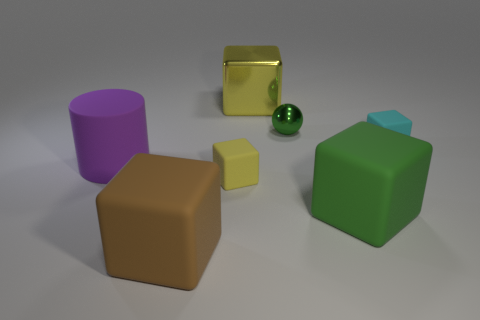Subtract all yellow blocks. How many were subtracted if there are1yellow blocks left? 1 Subtract all brown blocks. How many blocks are left? 4 Subtract all green matte blocks. How many blocks are left? 4 Subtract all blue cubes. Subtract all cyan cylinders. How many cubes are left? 5 Add 1 small yellow matte blocks. How many objects exist? 8 Subtract all spheres. How many objects are left? 6 Subtract 0 blue spheres. How many objects are left? 7 Subtract all yellow cubes. Subtract all small cyan things. How many objects are left? 4 Add 6 big metallic things. How many big metallic things are left? 7 Add 3 small purple rubber cylinders. How many small purple rubber cylinders exist? 3 